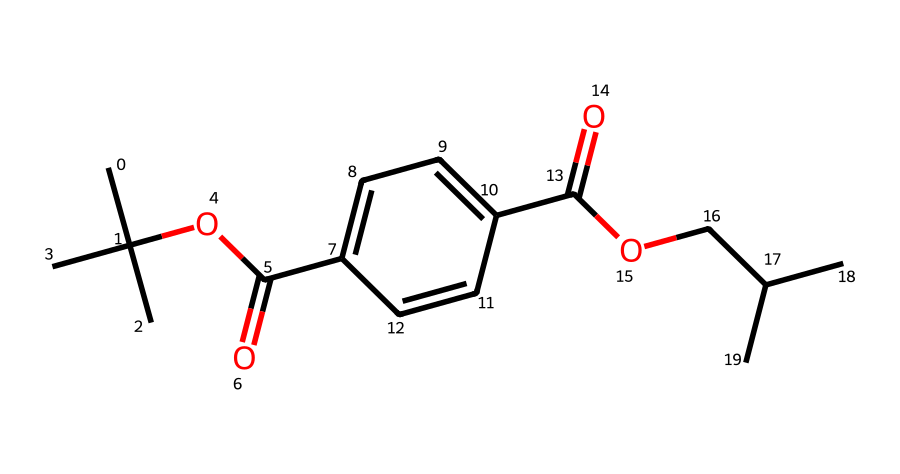What is the name of this chemical? The SMILES representation corresponds to polyethylene terephthalate (PET), a common type of plastic used in packaging.
Answer: polyethylene terephthalate How many carbon atoms are present in this structure? By analyzing the SMILES, you can count 18 carbon atoms throughout the structure (considering the branching and main chain areas).
Answer: 18 How many ester functional groups are present? The structure contains two carbonyl (C=O) groups connected to oxygen atoms indicating the presence of two ester functionalities.
Answer: 2 What type of polymer is indicated by the structure? The presence of repeating units formed by ester linkages signifies that this compound is a polyester.
Answer: polyester What is the molecular formula for this chemical? The molecular formula can be derived from the SMILES, yielding C18H34O4 based on the number of each type of atom present.
Answer: C18H34O4 How many oxygen atoms are in the structure? The SMILES includes four oxygen atoms, which can be identified in the ester and hydroxyl parts of the molecule.
Answer: 4 What characteristic feature of PET makes it suitable for electronic packaging? The presence of high thermal stability and chemical resistance resulting from the saturated carbon chain and ester groups makes PET ideal for electronic packaging.
Answer: thermal stability 